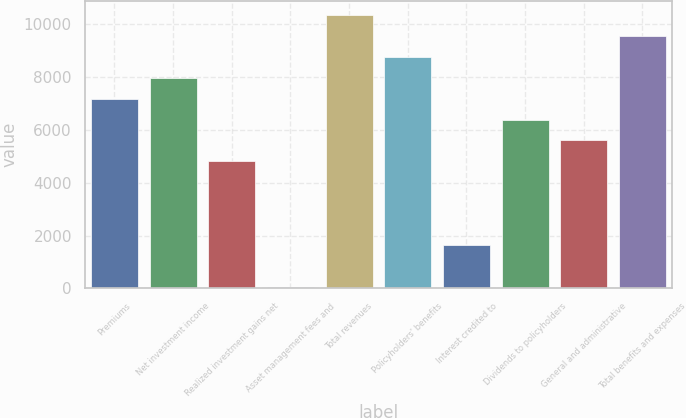<chart> <loc_0><loc_0><loc_500><loc_500><bar_chart><fcel>Premiums<fcel>Net investment income<fcel>Realized investment gains net<fcel>Asset management fees and<fcel>Total revenues<fcel>Policyholders' benefits<fcel>Interest credited to<fcel>Dividends to policyholders<fcel>General and administrative<fcel>Total benefits and expenses<nl><fcel>7188<fcel>7981<fcel>4809<fcel>51<fcel>10360<fcel>8774<fcel>1637<fcel>6395<fcel>5602<fcel>9567<nl></chart> 